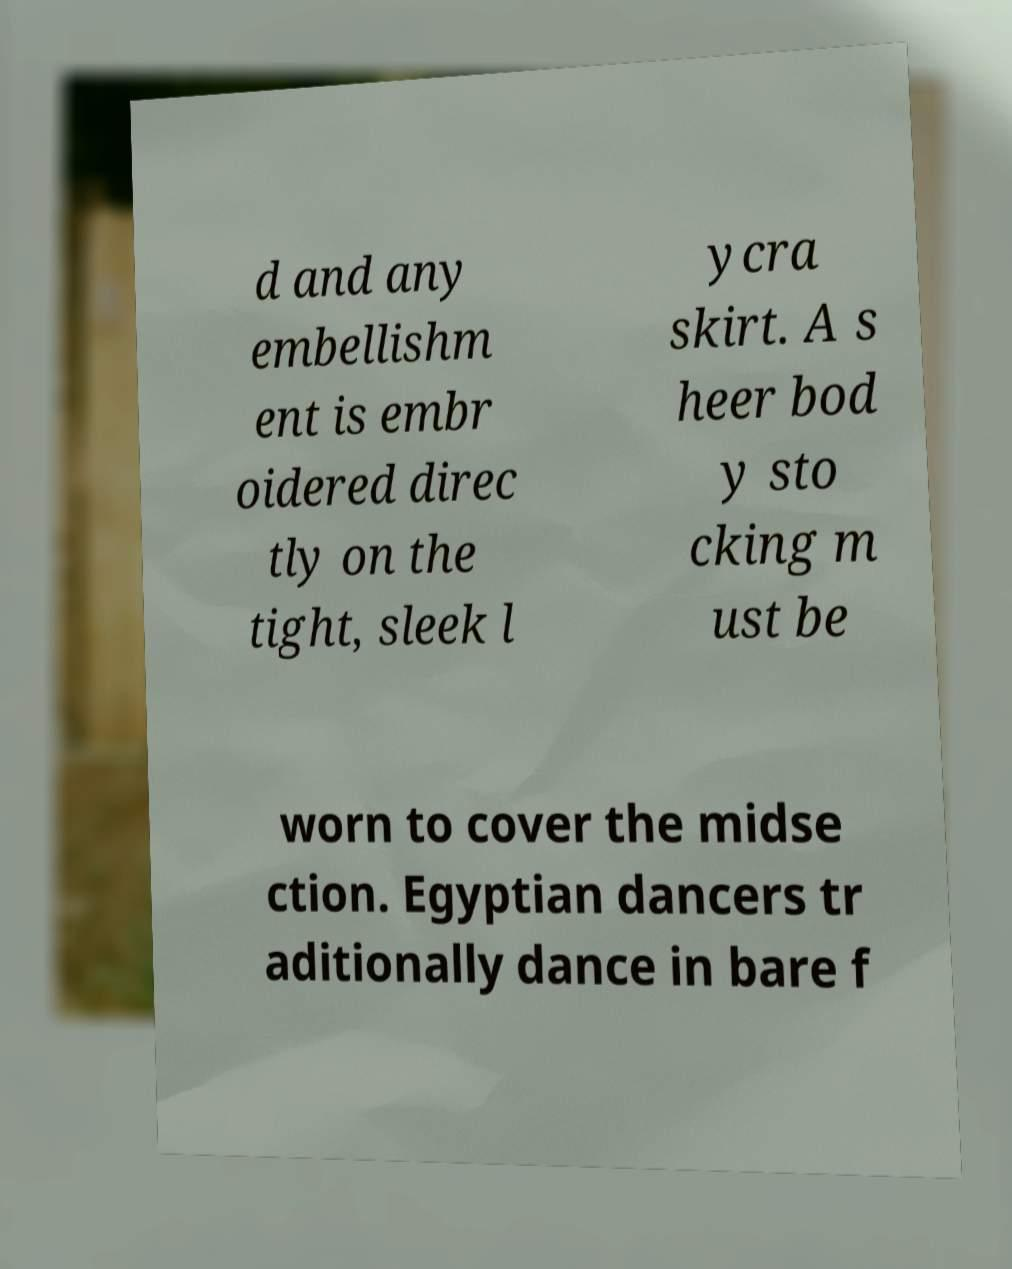There's text embedded in this image that I need extracted. Can you transcribe it verbatim? d and any embellishm ent is embr oidered direc tly on the tight, sleek l ycra skirt. A s heer bod y sto cking m ust be worn to cover the midse ction. Egyptian dancers tr aditionally dance in bare f 